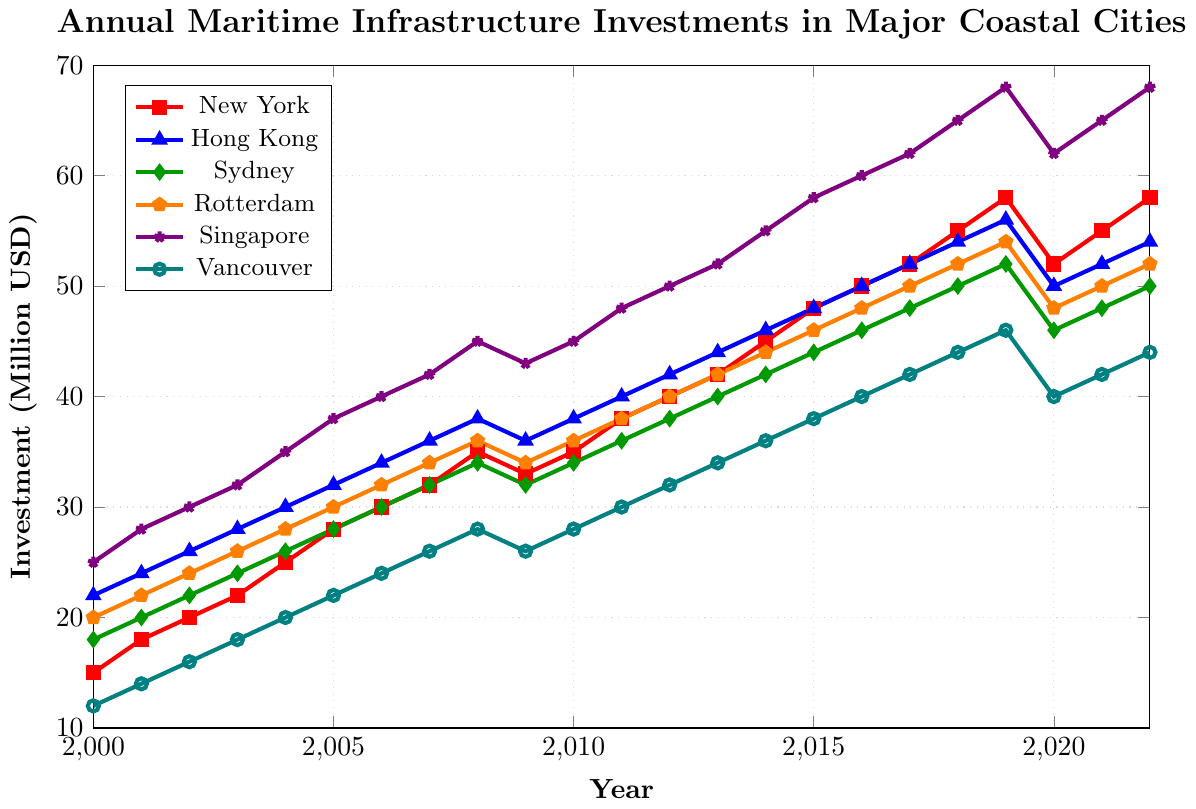What city had the highest investment in 2022? By identifying the highest data point in 2022 on the y-axis, Singapore’s investment is the highest.
Answer: Singapore How did New York's investments change from 2008 to 2009? Examine the line for New York between 2008 and 2009, noting the decrease from 35 to 33 million USD.
Answer: Decreased Which city shows a dip in investment in 2020? Refer to the investment curves for 2020 and identify all cities that experienced a decrease compared to 2019. These are New York, Hong Kong, Sydney, Rotterdam, Singapore, and Vancouver.
Answer: Multiple cities What is the difference in investment between Singapore and Vancouver in 2022? Look at Singapore and Vancouver's investment values for 2022, calculate the difference: 68 million USD (Singapore) - 44 million USD (Vancouver) = 24 million USD.
Answer: 24 million USD What year did Sydney reach an investment of 50 million USD? By following the curve for Sydney, it reaches 50 million USD in 2018.
Answer: 2018 What is the trend in Hong Kong's investment between 2000 and 2022? Review Hong Kong's investment curve from 2000 to 2022, noting the general upward trajectory.
Answer: Increasing By how much did Rotterdam's investment increase from 2000 to 2015? Compare Rotterdam's investment values in 2000 (20 million USD) and 2015 (46 million USD), calculating the increase: 46 - 20 = 26 million USD.
Answer: 26 million USD Which city's investments remained highest among all cities for the majority of the years? Track the highest investment curve throughout the years from 2000 to 2022, noting Singapore is consistently the highest.
Answer: Singapore What was the average investment for Vancouver from 2000 to 2022? Sum Vancouver’s investments from 2000 to 2022 and divide by the number of years: (Total = 554) / 23 years = 24.08 million USD.
Answer: 24.08 million USD 